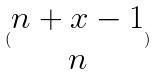<formula> <loc_0><loc_0><loc_500><loc_500>( \begin{matrix} n + x - 1 \\ n \end{matrix} )</formula> 